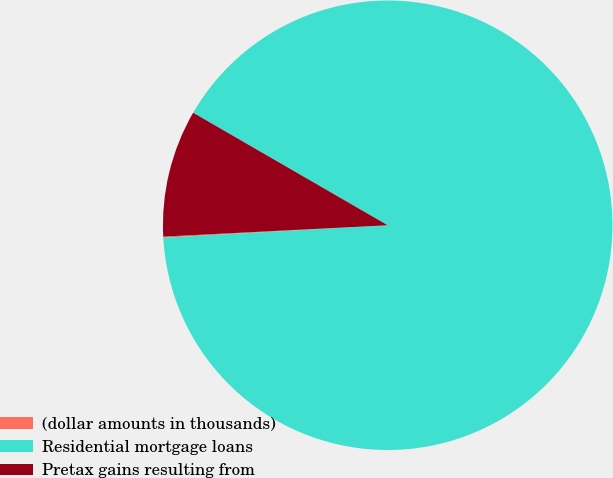Convert chart. <chart><loc_0><loc_0><loc_500><loc_500><pie_chart><fcel>(dollar amounts in thousands)<fcel>Residential mortgage loans<fcel>Pretax gains resulting from<nl><fcel>0.08%<fcel>90.77%<fcel>9.15%<nl></chart> 